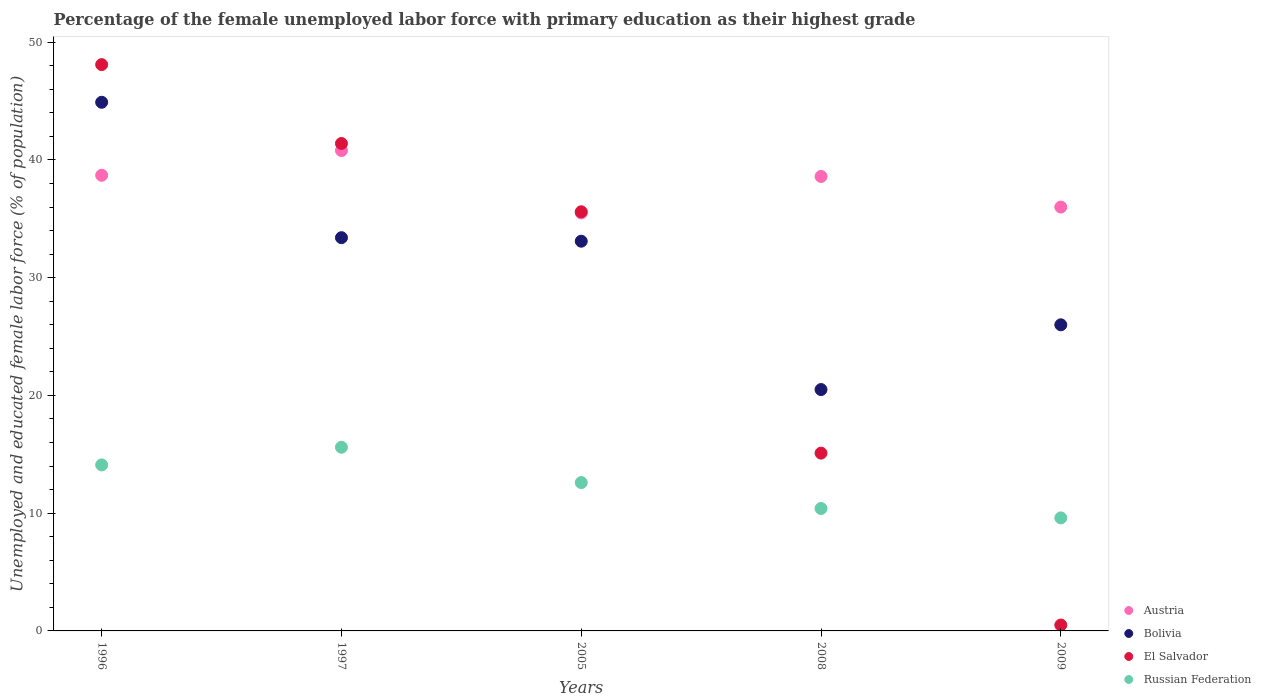How many different coloured dotlines are there?
Provide a succinct answer. 4. Is the number of dotlines equal to the number of legend labels?
Your answer should be very brief. Yes. What is the percentage of the unemployed female labor force with primary education in El Salvador in 2008?
Offer a very short reply. 15.1. Across all years, what is the maximum percentage of the unemployed female labor force with primary education in Russian Federation?
Make the answer very short. 15.6. In which year was the percentage of the unemployed female labor force with primary education in Austria maximum?
Keep it short and to the point. 1997. What is the total percentage of the unemployed female labor force with primary education in El Salvador in the graph?
Your response must be concise. 140.7. What is the difference between the percentage of the unemployed female labor force with primary education in Bolivia in 1996 and that in 2008?
Keep it short and to the point. 24.4. What is the difference between the percentage of the unemployed female labor force with primary education in Bolivia in 2008 and the percentage of the unemployed female labor force with primary education in El Salvador in 2009?
Give a very brief answer. 20. What is the average percentage of the unemployed female labor force with primary education in Austria per year?
Ensure brevity in your answer.  37.92. In the year 1996, what is the difference between the percentage of the unemployed female labor force with primary education in Bolivia and percentage of the unemployed female labor force with primary education in Russian Federation?
Your response must be concise. 30.8. What is the ratio of the percentage of the unemployed female labor force with primary education in Austria in 2005 to that in 2009?
Your response must be concise. 0.99. What is the difference between the highest and the second highest percentage of the unemployed female labor force with primary education in El Salvador?
Your response must be concise. 6.7. What is the difference between the highest and the lowest percentage of the unemployed female labor force with primary education in Austria?
Ensure brevity in your answer.  5.3. In how many years, is the percentage of the unemployed female labor force with primary education in El Salvador greater than the average percentage of the unemployed female labor force with primary education in El Salvador taken over all years?
Make the answer very short. 3. Is the percentage of the unemployed female labor force with primary education in El Salvador strictly greater than the percentage of the unemployed female labor force with primary education in Bolivia over the years?
Make the answer very short. No. What is the difference between two consecutive major ticks on the Y-axis?
Your response must be concise. 10. Are the values on the major ticks of Y-axis written in scientific E-notation?
Your response must be concise. No. Does the graph contain any zero values?
Offer a very short reply. No. Does the graph contain grids?
Provide a short and direct response. No. What is the title of the graph?
Give a very brief answer. Percentage of the female unemployed labor force with primary education as their highest grade. Does "Kuwait" appear as one of the legend labels in the graph?
Keep it short and to the point. No. What is the label or title of the Y-axis?
Your answer should be very brief. Unemployed and educated female labor force (% of population). What is the Unemployed and educated female labor force (% of population) of Austria in 1996?
Keep it short and to the point. 38.7. What is the Unemployed and educated female labor force (% of population) in Bolivia in 1996?
Give a very brief answer. 44.9. What is the Unemployed and educated female labor force (% of population) of El Salvador in 1996?
Give a very brief answer. 48.1. What is the Unemployed and educated female labor force (% of population) in Russian Federation in 1996?
Give a very brief answer. 14.1. What is the Unemployed and educated female labor force (% of population) of Austria in 1997?
Your response must be concise. 40.8. What is the Unemployed and educated female labor force (% of population) in Bolivia in 1997?
Make the answer very short. 33.4. What is the Unemployed and educated female labor force (% of population) of El Salvador in 1997?
Your answer should be compact. 41.4. What is the Unemployed and educated female labor force (% of population) of Russian Federation in 1997?
Keep it short and to the point. 15.6. What is the Unemployed and educated female labor force (% of population) in Austria in 2005?
Make the answer very short. 35.5. What is the Unemployed and educated female labor force (% of population) of Bolivia in 2005?
Provide a short and direct response. 33.1. What is the Unemployed and educated female labor force (% of population) in El Salvador in 2005?
Keep it short and to the point. 35.6. What is the Unemployed and educated female labor force (% of population) in Russian Federation in 2005?
Ensure brevity in your answer.  12.6. What is the Unemployed and educated female labor force (% of population) of Austria in 2008?
Offer a terse response. 38.6. What is the Unemployed and educated female labor force (% of population) of El Salvador in 2008?
Give a very brief answer. 15.1. What is the Unemployed and educated female labor force (% of population) of Russian Federation in 2008?
Provide a succinct answer. 10.4. What is the Unemployed and educated female labor force (% of population) in Bolivia in 2009?
Offer a terse response. 26. What is the Unemployed and educated female labor force (% of population) of Russian Federation in 2009?
Give a very brief answer. 9.6. Across all years, what is the maximum Unemployed and educated female labor force (% of population) of Austria?
Give a very brief answer. 40.8. Across all years, what is the maximum Unemployed and educated female labor force (% of population) in Bolivia?
Provide a short and direct response. 44.9. Across all years, what is the maximum Unemployed and educated female labor force (% of population) in El Salvador?
Keep it short and to the point. 48.1. Across all years, what is the maximum Unemployed and educated female labor force (% of population) of Russian Federation?
Provide a short and direct response. 15.6. Across all years, what is the minimum Unemployed and educated female labor force (% of population) in Austria?
Provide a succinct answer. 35.5. Across all years, what is the minimum Unemployed and educated female labor force (% of population) in El Salvador?
Ensure brevity in your answer.  0.5. Across all years, what is the minimum Unemployed and educated female labor force (% of population) of Russian Federation?
Ensure brevity in your answer.  9.6. What is the total Unemployed and educated female labor force (% of population) of Austria in the graph?
Keep it short and to the point. 189.6. What is the total Unemployed and educated female labor force (% of population) in Bolivia in the graph?
Offer a terse response. 157.9. What is the total Unemployed and educated female labor force (% of population) in El Salvador in the graph?
Your answer should be compact. 140.7. What is the total Unemployed and educated female labor force (% of population) of Russian Federation in the graph?
Keep it short and to the point. 62.3. What is the difference between the Unemployed and educated female labor force (% of population) in Austria in 1996 and that in 1997?
Your answer should be compact. -2.1. What is the difference between the Unemployed and educated female labor force (% of population) in El Salvador in 1996 and that in 1997?
Offer a terse response. 6.7. What is the difference between the Unemployed and educated female labor force (% of population) of Russian Federation in 1996 and that in 1997?
Make the answer very short. -1.5. What is the difference between the Unemployed and educated female labor force (% of population) in Austria in 1996 and that in 2008?
Offer a very short reply. 0.1. What is the difference between the Unemployed and educated female labor force (% of population) in Bolivia in 1996 and that in 2008?
Your answer should be compact. 24.4. What is the difference between the Unemployed and educated female labor force (% of population) of Russian Federation in 1996 and that in 2008?
Keep it short and to the point. 3.7. What is the difference between the Unemployed and educated female labor force (% of population) of El Salvador in 1996 and that in 2009?
Your answer should be very brief. 47.6. What is the difference between the Unemployed and educated female labor force (% of population) in El Salvador in 1997 and that in 2005?
Offer a terse response. 5.8. What is the difference between the Unemployed and educated female labor force (% of population) of Russian Federation in 1997 and that in 2005?
Ensure brevity in your answer.  3. What is the difference between the Unemployed and educated female labor force (% of population) in El Salvador in 1997 and that in 2008?
Your answer should be compact. 26.3. What is the difference between the Unemployed and educated female labor force (% of population) in Russian Federation in 1997 and that in 2008?
Your answer should be very brief. 5.2. What is the difference between the Unemployed and educated female labor force (% of population) in Austria in 1997 and that in 2009?
Offer a very short reply. 4.8. What is the difference between the Unemployed and educated female labor force (% of population) of Bolivia in 1997 and that in 2009?
Make the answer very short. 7.4. What is the difference between the Unemployed and educated female labor force (% of population) in El Salvador in 1997 and that in 2009?
Give a very brief answer. 40.9. What is the difference between the Unemployed and educated female labor force (% of population) of El Salvador in 2005 and that in 2008?
Your answer should be very brief. 20.5. What is the difference between the Unemployed and educated female labor force (% of population) of Russian Federation in 2005 and that in 2008?
Offer a terse response. 2.2. What is the difference between the Unemployed and educated female labor force (% of population) in Bolivia in 2005 and that in 2009?
Provide a succinct answer. 7.1. What is the difference between the Unemployed and educated female labor force (% of population) of El Salvador in 2005 and that in 2009?
Keep it short and to the point. 35.1. What is the difference between the Unemployed and educated female labor force (% of population) in Austria in 2008 and that in 2009?
Make the answer very short. 2.6. What is the difference between the Unemployed and educated female labor force (% of population) in Austria in 1996 and the Unemployed and educated female labor force (% of population) in Russian Federation in 1997?
Keep it short and to the point. 23.1. What is the difference between the Unemployed and educated female labor force (% of population) in Bolivia in 1996 and the Unemployed and educated female labor force (% of population) in Russian Federation in 1997?
Offer a very short reply. 29.3. What is the difference between the Unemployed and educated female labor force (% of population) in El Salvador in 1996 and the Unemployed and educated female labor force (% of population) in Russian Federation in 1997?
Ensure brevity in your answer.  32.5. What is the difference between the Unemployed and educated female labor force (% of population) in Austria in 1996 and the Unemployed and educated female labor force (% of population) in Bolivia in 2005?
Offer a very short reply. 5.6. What is the difference between the Unemployed and educated female labor force (% of population) of Austria in 1996 and the Unemployed and educated female labor force (% of population) of El Salvador in 2005?
Give a very brief answer. 3.1. What is the difference between the Unemployed and educated female labor force (% of population) of Austria in 1996 and the Unemployed and educated female labor force (% of population) of Russian Federation in 2005?
Offer a terse response. 26.1. What is the difference between the Unemployed and educated female labor force (% of population) in Bolivia in 1996 and the Unemployed and educated female labor force (% of population) in El Salvador in 2005?
Ensure brevity in your answer.  9.3. What is the difference between the Unemployed and educated female labor force (% of population) of Bolivia in 1996 and the Unemployed and educated female labor force (% of population) of Russian Federation in 2005?
Keep it short and to the point. 32.3. What is the difference between the Unemployed and educated female labor force (% of population) of El Salvador in 1996 and the Unemployed and educated female labor force (% of population) of Russian Federation in 2005?
Give a very brief answer. 35.5. What is the difference between the Unemployed and educated female labor force (% of population) in Austria in 1996 and the Unemployed and educated female labor force (% of population) in Bolivia in 2008?
Make the answer very short. 18.2. What is the difference between the Unemployed and educated female labor force (% of population) in Austria in 1996 and the Unemployed and educated female labor force (% of population) in El Salvador in 2008?
Your answer should be very brief. 23.6. What is the difference between the Unemployed and educated female labor force (% of population) in Austria in 1996 and the Unemployed and educated female labor force (% of population) in Russian Federation in 2008?
Keep it short and to the point. 28.3. What is the difference between the Unemployed and educated female labor force (% of population) in Bolivia in 1996 and the Unemployed and educated female labor force (% of population) in El Salvador in 2008?
Give a very brief answer. 29.8. What is the difference between the Unemployed and educated female labor force (% of population) of Bolivia in 1996 and the Unemployed and educated female labor force (% of population) of Russian Federation in 2008?
Make the answer very short. 34.5. What is the difference between the Unemployed and educated female labor force (% of population) in El Salvador in 1996 and the Unemployed and educated female labor force (% of population) in Russian Federation in 2008?
Ensure brevity in your answer.  37.7. What is the difference between the Unemployed and educated female labor force (% of population) in Austria in 1996 and the Unemployed and educated female labor force (% of population) in Bolivia in 2009?
Provide a succinct answer. 12.7. What is the difference between the Unemployed and educated female labor force (% of population) in Austria in 1996 and the Unemployed and educated female labor force (% of population) in El Salvador in 2009?
Offer a very short reply. 38.2. What is the difference between the Unemployed and educated female labor force (% of population) in Austria in 1996 and the Unemployed and educated female labor force (% of population) in Russian Federation in 2009?
Keep it short and to the point. 29.1. What is the difference between the Unemployed and educated female labor force (% of population) of Bolivia in 1996 and the Unemployed and educated female labor force (% of population) of El Salvador in 2009?
Give a very brief answer. 44.4. What is the difference between the Unemployed and educated female labor force (% of population) in Bolivia in 1996 and the Unemployed and educated female labor force (% of population) in Russian Federation in 2009?
Give a very brief answer. 35.3. What is the difference between the Unemployed and educated female labor force (% of population) of El Salvador in 1996 and the Unemployed and educated female labor force (% of population) of Russian Federation in 2009?
Ensure brevity in your answer.  38.5. What is the difference between the Unemployed and educated female labor force (% of population) in Austria in 1997 and the Unemployed and educated female labor force (% of population) in Bolivia in 2005?
Give a very brief answer. 7.7. What is the difference between the Unemployed and educated female labor force (% of population) in Austria in 1997 and the Unemployed and educated female labor force (% of population) in El Salvador in 2005?
Offer a very short reply. 5.2. What is the difference between the Unemployed and educated female labor force (% of population) in Austria in 1997 and the Unemployed and educated female labor force (% of population) in Russian Federation in 2005?
Provide a succinct answer. 28.2. What is the difference between the Unemployed and educated female labor force (% of population) of Bolivia in 1997 and the Unemployed and educated female labor force (% of population) of Russian Federation in 2005?
Keep it short and to the point. 20.8. What is the difference between the Unemployed and educated female labor force (% of population) in El Salvador in 1997 and the Unemployed and educated female labor force (% of population) in Russian Federation in 2005?
Your response must be concise. 28.8. What is the difference between the Unemployed and educated female labor force (% of population) in Austria in 1997 and the Unemployed and educated female labor force (% of population) in Bolivia in 2008?
Provide a succinct answer. 20.3. What is the difference between the Unemployed and educated female labor force (% of population) in Austria in 1997 and the Unemployed and educated female labor force (% of population) in El Salvador in 2008?
Offer a very short reply. 25.7. What is the difference between the Unemployed and educated female labor force (% of population) of Austria in 1997 and the Unemployed and educated female labor force (% of population) of Russian Federation in 2008?
Keep it short and to the point. 30.4. What is the difference between the Unemployed and educated female labor force (% of population) in Bolivia in 1997 and the Unemployed and educated female labor force (% of population) in El Salvador in 2008?
Ensure brevity in your answer.  18.3. What is the difference between the Unemployed and educated female labor force (% of population) in Bolivia in 1997 and the Unemployed and educated female labor force (% of population) in Russian Federation in 2008?
Your answer should be very brief. 23. What is the difference between the Unemployed and educated female labor force (% of population) of Austria in 1997 and the Unemployed and educated female labor force (% of population) of Bolivia in 2009?
Keep it short and to the point. 14.8. What is the difference between the Unemployed and educated female labor force (% of population) of Austria in 1997 and the Unemployed and educated female labor force (% of population) of El Salvador in 2009?
Give a very brief answer. 40.3. What is the difference between the Unemployed and educated female labor force (% of population) of Austria in 1997 and the Unemployed and educated female labor force (% of population) of Russian Federation in 2009?
Provide a short and direct response. 31.2. What is the difference between the Unemployed and educated female labor force (% of population) of Bolivia in 1997 and the Unemployed and educated female labor force (% of population) of El Salvador in 2009?
Ensure brevity in your answer.  32.9. What is the difference between the Unemployed and educated female labor force (% of population) of Bolivia in 1997 and the Unemployed and educated female labor force (% of population) of Russian Federation in 2009?
Provide a short and direct response. 23.8. What is the difference between the Unemployed and educated female labor force (% of population) in El Salvador in 1997 and the Unemployed and educated female labor force (% of population) in Russian Federation in 2009?
Give a very brief answer. 31.8. What is the difference between the Unemployed and educated female labor force (% of population) in Austria in 2005 and the Unemployed and educated female labor force (% of population) in El Salvador in 2008?
Provide a short and direct response. 20.4. What is the difference between the Unemployed and educated female labor force (% of population) in Austria in 2005 and the Unemployed and educated female labor force (% of population) in Russian Federation in 2008?
Provide a succinct answer. 25.1. What is the difference between the Unemployed and educated female labor force (% of population) in Bolivia in 2005 and the Unemployed and educated female labor force (% of population) in El Salvador in 2008?
Your response must be concise. 18. What is the difference between the Unemployed and educated female labor force (% of population) in Bolivia in 2005 and the Unemployed and educated female labor force (% of population) in Russian Federation in 2008?
Your answer should be very brief. 22.7. What is the difference between the Unemployed and educated female labor force (% of population) of El Salvador in 2005 and the Unemployed and educated female labor force (% of population) of Russian Federation in 2008?
Provide a short and direct response. 25.2. What is the difference between the Unemployed and educated female labor force (% of population) of Austria in 2005 and the Unemployed and educated female labor force (% of population) of Bolivia in 2009?
Your answer should be very brief. 9.5. What is the difference between the Unemployed and educated female labor force (% of population) in Austria in 2005 and the Unemployed and educated female labor force (% of population) in El Salvador in 2009?
Keep it short and to the point. 35. What is the difference between the Unemployed and educated female labor force (% of population) in Austria in 2005 and the Unemployed and educated female labor force (% of population) in Russian Federation in 2009?
Your answer should be very brief. 25.9. What is the difference between the Unemployed and educated female labor force (% of population) in Bolivia in 2005 and the Unemployed and educated female labor force (% of population) in El Salvador in 2009?
Offer a terse response. 32.6. What is the difference between the Unemployed and educated female labor force (% of population) in El Salvador in 2005 and the Unemployed and educated female labor force (% of population) in Russian Federation in 2009?
Your response must be concise. 26. What is the difference between the Unemployed and educated female labor force (% of population) in Austria in 2008 and the Unemployed and educated female labor force (% of population) in Bolivia in 2009?
Make the answer very short. 12.6. What is the difference between the Unemployed and educated female labor force (% of population) of Austria in 2008 and the Unemployed and educated female labor force (% of population) of El Salvador in 2009?
Offer a terse response. 38.1. What is the difference between the Unemployed and educated female labor force (% of population) of Austria in 2008 and the Unemployed and educated female labor force (% of population) of Russian Federation in 2009?
Provide a short and direct response. 29. What is the difference between the Unemployed and educated female labor force (% of population) in Bolivia in 2008 and the Unemployed and educated female labor force (% of population) in El Salvador in 2009?
Offer a very short reply. 20. What is the average Unemployed and educated female labor force (% of population) in Austria per year?
Offer a very short reply. 37.92. What is the average Unemployed and educated female labor force (% of population) of Bolivia per year?
Your answer should be compact. 31.58. What is the average Unemployed and educated female labor force (% of population) of El Salvador per year?
Your answer should be compact. 28.14. What is the average Unemployed and educated female labor force (% of population) of Russian Federation per year?
Your response must be concise. 12.46. In the year 1996, what is the difference between the Unemployed and educated female labor force (% of population) in Austria and Unemployed and educated female labor force (% of population) in Bolivia?
Give a very brief answer. -6.2. In the year 1996, what is the difference between the Unemployed and educated female labor force (% of population) in Austria and Unemployed and educated female labor force (% of population) in El Salvador?
Give a very brief answer. -9.4. In the year 1996, what is the difference between the Unemployed and educated female labor force (% of population) of Austria and Unemployed and educated female labor force (% of population) of Russian Federation?
Make the answer very short. 24.6. In the year 1996, what is the difference between the Unemployed and educated female labor force (% of population) of Bolivia and Unemployed and educated female labor force (% of population) of El Salvador?
Give a very brief answer. -3.2. In the year 1996, what is the difference between the Unemployed and educated female labor force (% of population) in Bolivia and Unemployed and educated female labor force (% of population) in Russian Federation?
Provide a short and direct response. 30.8. In the year 1996, what is the difference between the Unemployed and educated female labor force (% of population) in El Salvador and Unemployed and educated female labor force (% of population) in Russian Federation?
Offer a very short reply. 34. In the year 1997, what is the difference between the Unemployed and educated female labor force (% of population) in Austria and Unemployed and educated female labor force (% of population) in Bolivia?
Your answer should be compact. 7.4. In the year 1997, what is the difference between the Unemployed and educated female labor force (% of population) in Austria and Unemployed and educated female labor force (% of population) in Russian Federation?
Offer a very short reply. 25.2. In the year 1997, what is the difference between the Unemployed and educated female labor force (% of population) of Bolivia and Unemployed and educated female labor force (% of population) of El Salvador?
Offer a terse response. -8. In the year 1997, what is the difference between the Unemployed and educated female labor force (% of population) in Bolivia and Unemployed and educated female labor force (% of population) in Russian Federation?
Ensure brevity in your answer.  17.8. In the year 1997, what is the difference between the Unemployed and educated female labor force (% of population) in El Salvador and Unemployed and educated female labor force (% of population) in Russian Federation?
Provide a short and direct response. 25.8. In the year 2005, what is the difference between the Unemployed and educated female labor force (% of population) of Austria and Unemployed and educated female labor force (% of population) of Bolivia?
Offer a very short reply. 2.4. In the year 2005, what is the difference between the Unemployed and educated female labor force (% of population) of Austria and Unemployed and educated female labor force (% of population) of El Salvador?
Your answer should be very brief. -0.1. In the year 2005, what is the difference between the Unemployed and educated female labor force (% of population) in Austria and Unemployed and educated female labor force (% of population) in Russian Federation?
Provide a short and direct response. 22.9. In the year 2005, what is the difference between the Unemployed and educated female labor force (% of population) in Bolivia and Unemployed and educated female labor force (% of population) in El Salvador?
Make the answer very short. -2.5. In the year 2008, what is the difference between the Unemployed and educated female labor force (% of population) of Austria and Unemployed and educated female labor force (% of population) of Bolivia?
Ensure brevity in your answer.  18.1. In the year 2008, what is the difference between the Unemployed and educated female labor force (% of population) of Austria and Unemployed and educated female labor force (% of population) of Russian Federation?
Your response must be concise. 28.2. In the year 2008, what is the difference between the Unemployed and educated female labor force (% of population) in Bolivia and Unemployed and educated female labor force (% of population) in Russian Federation?
Your answer should be very brief. 10.1. In the year 2008, what is the difference between the Unemployed and educated female labor force (% of population) of El Salvador and Unemployed and educated female labor force (% of population) of Russian Federation?
Ensure brevity in your answer.  4.7. In the year 2009, what is the difference between the Unemployed and educated female labor force (% of population) of Austria and Unemployed and educated female labor force (% of population) of Bolivia?
Ensure brevity in your answer.  10. In the year 2009, what is the difference between the Unemployed and educated female labor force (% of population) of Austria and Unemployed and educated female labor force (% of population) of El Salvador?
Your answer should be very brief. 35.5. In the year 2009, what is the difference between the Unemployed and educated female labor force (% of population) of Austria and Unemployed and educated female labor force (% of population) of Russian Federation?
Give a very brief answer. 26.4. What is the ratio of the Unemployed and educated female labor force (% of population) of Austria in 1996 to that in 1997?
Your response must be concise. 0.95. What is the ratio of the Unemployed and educated female labor force (% of population) in Bolivia in 1996 to that in 1997?
Your answer should be very brief. 1.34. What is the ratio of the Unemployed and educated female labor force (% of population) in El Salvador in 1996 to that in 1997?
Your answer should be compact. 1.16. What is the ratio of the Unemployed and educated female labor force (% of population) in Russian Federation in 1996 to that in 1997?
Provide a short and direct response. 0.9. What is the ratio of the Unemployed and educated female labor force (% of population) of Austria in 1996 to that in 2005?
Your answer should be very brief. 1.09. What is the ratio of the Unemployed and educated female labor force (% of population) in Bolivia in 1996 to that in 2005?
Your response must be concise. 1.36. What is the ratio of the Unemployed and educated female labor force (% of population) in El Salvador in 1996 to that in 2005?
Ensure brevity in your answer.  1.35. What is the ratio of the Unemployed and educated female labor force (% of population) of Russian Federation in 1996 to that in 2005?
Provide a succinct answer. 1.12. What is the ratio of the Unemployed and educated female labor force (% of population) in Austria in 1996 to that in 2008?
Provide a succinct answer. 1. What is the ratio of the Unemployed and educated female labor force (% of population) in Bolivia in 1996 to that in 2008?
Your answer should be very brief. 2.19. What is the ratio of the Unemployed and educated female labor force (% of population) in El Salvador in 1996 to that in 2008?
Your answer should be very brief. 3.19. What is the ratio of the Unemployed and educated female labor force (% of population) of Russian Federation in 1996 to that in 2008?
Ensure brevity in your answer.  1.36. What is the ratio of the Unemployed and educated female labor force (% of population) of Austria in 1996 to that in 2009?
Provide a succinct answer. 1.07. What is the ratio of the Unemployed and educated female labor force (% of population) in Bolivia in 1996 to that in 2009?
Your answer should be very brief. 1.73. What is the ratio of the Unemployed and educated female labor force (% of population) of El Salvador in 1996 to that in 2009?
Offer a terse response. 96.2. What is the ratio of the Unemployed and educated female labor force (% of population) of Russian Federation in 1996 to that in 2009?
Offer a very short reply. 1.47. What is the ratio of the Unemployed and educated female labor force (% of population) of Austria in 1997 to that in 2005?
Your response must be concise. 1.15. What is the ratio of the Unemployed and educated female labor force (% of population) of Bolivia in 1997 to that in 2005?
Keep it short and to the point. 1.01. What is the ratio of the Unemployed and educated female labor force (% of population) in El Salvador in 1997 to that in 2005?
Provide a short and direct response. 1.16. What is the ratio of the Unemployed and educated female labor force (% of population) of Russian Federation in 1997 to that in 2005?
Your answer should be very brief. 1.24. What is the ratio of the Unemployed and educated female labor force (% of population) in Austria in 1997 to that in 2008?
Ensure brevity in your answer.  1.06. What is the ratio of the Unemployed and educated female labor force (% of population) in Bolivia in 1997 to that in 2008?
Make the answer very short. 1.63. What is the ratio of the Unemployed and educated female labor force (% of population) in El Salvador in 1997 to that in 2008?
Your answer should be compact. 2.74. What is the ratio of the Unemployed and educated female labor force (% of population) of Austria in 1997 to that in 2009?
Ensure brevity in your answer.  1.13. What is the ratio of the Unemployed and educated female labor force (% of population) of Bolivia in 1997 to that in 2009?
Give a very brief answer. 1.28. What is the ratio of the Unemployed and educated female labor force (% of population) in El Salvador in 1997 to that in 2009?
Your response must be concise. 82.8. What is the ratio of the Unemployed and educated female labor force (% of population) in Russian Federation in 1997 to that in 2009?
Your answer should be compact. 1.62. What is the ratio of the Unemployed and educated female labor force (% of population) of Austria in 2005 to that in 2008?
Provide a succinct answer. 0.92. What is the ratio of the Unemployed and educated female labor force (% of population) of Bolivia in 2005 to that in 2008?
Provide a short and direct response. 1.61. What is the ratio of the Unemployed and educated female labor force (% of population) of El Salvador in 2005 to that in 2008?
Give a very brief answer. 2.36. What is the ratio of the Unemployed and educated female labor force (% of population) of Russian Federation in 2005 to that in 2008?
Give a very brief answer. 1.21. What is the ratio of the Unemployed and educated female labor force (% of population) in Austria in 2005 to that in 2009?
Offer a very short reply. 0.99. What is the ratio of the Unemployed and educated female labor force (% of population) of Bolivia in 2005 to that in 2009?
Offer a terse response. 1.27. What is the ratio of the Unemployed and educated female labor force (% of population) of El Salvador in 2005 to that in 2009?
Make the answer very short. 71.2. What is the ratio of the Unemployed and educated female labor force (% of population) of Russian Federation in 2005 to that in 2009?
Ensure brevity in your answer.  1.31. What is the ratio of the Unemployed and educated female labor force (% of population) of Austria in 2008 to that in 2009?
Keep it short and to the point. 1.07. What is the ratio of the Unemployed and educated female labor force (% of population) of Bolivia in 2008 to that in 2009?
Ensure brevity in your answer.  0.79. What is the ratio of the Unemployed and educated female labor force (% of population) in El Salvador in 2008 to that in 2009?
Offer a very short reply. 30.2. What is the ratio of the Unemployed and educated female labor force (% of population) in Russian Federation in 2008 to that in 2009?
Make the answer very short. 1.08. What is the difference between the highest and the lowest Unemployed and educated female labor force (% of population) of Bolivia?
Your answer should be very brief. 24.4. What is the difference between the highest and the lowest Unemployed and educated female labor force (% of population) of El Salvador?
Ensure brevity in your answer.  47.6. 